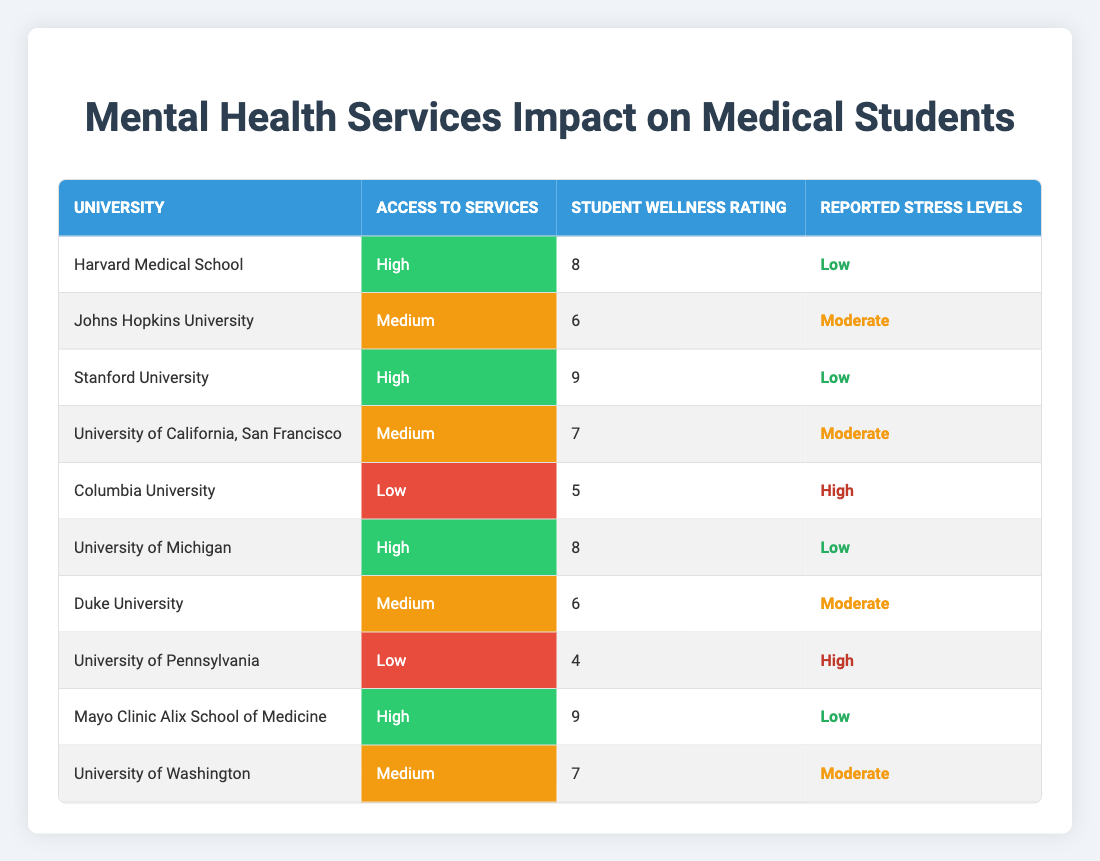What is the student wellness rating for Stanford University? According to the table, Stanford University's Student Wellness Rating is listed as 9.
Answer: 9 Which universities have low access to mental health services? The table shows that Columbia University and the University of Pennsylvania have low access to mental health services.
Answer: Columbia University, University of Pennsylvania Is the reported stress level at Harvard Medical School low? Yes, the table indicates that the reported stress level for Harvard Medical School is categorized as low.
Answer: Yes What is the average student wellness rating for universities with high access to services? The universities with high access to services are Harvard Medical School (8), Stanford University (9), University of Michigan (8), and Mayo Clinic Alix School of Medicine (9). Summing these ratings: 8 + 9 + 8 + 9 = 34. There are 4 universities, so the average is 34/4 = 8.5.
Answer: 8.5 Which university has the lowest reported stress levels? By reviewing the reported stress levels in the table, Harvard Medical School, Stanford University, University of Michigan, and Mayo Clinic Alix School of Medicine have low stress levels. Since the question seeks the lowest, all these universities share this category, but we cannot rank them further as they all equally have low stress reported.
Answer: Multiple universities Are there any universities with a medium access to services and a wellness rating higher than 7? The table shows that Johns Hopkins University (wellness rating 6), University of California, San Francisco (7), Duke University (6), and University of Washington (7) have medium access. None have a rating higher than 7. Thus, no universities fit the criteria.
Answer: No How many universities have high access to mental health services and have a student wellness rating of 8 or more? The high access universities with ratings of 8 or more are Harvard Medical School (8), Stanford University (9), University of Michigan (8), and Mayo Clinic Alix School of Medicine (9). There are 4 universities that meet the criteria.
Answer: 4 Does any university with low access to services have a student wellness rating of 6 or more? Columbia University has a low access rating with a wellness rating of 5, while University of Pennsylvania has a wellness rating of 4. Neither has a rating of 6 or more. Therefore, the answer is no.
Answer: No What is the difference in student wellness ratings between high and low access service universities? The average wellness rating for high access universities is 8.5 (as calculated) while for low access (Columbia University: 5, University of Pennsylvania: 4) it is (5 + 4)/2 = 4.5. The difference is 8.5 - 4.5 = 4.
Answer: 4 